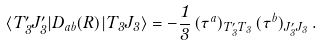Convert formula to latex. <formula><loc_0><loc_0><loc_500><loc_500>\langle T _ { 3 } ^ { \prime } J _ { 3 } ^ { \prime } | D _ { a b } ( R ) | T _ { 3 } J _ { 3 } \rangle = - \frac { 1 } { 3 } \, ( \tau ^ { a } ) _ { T _ { 3 } ^ { \prime } T _ { 3 } } \, ( \tau ^ { b } ) _ { J _ { 3 } ^ { \prime } J _ { 3 } } \, .</formula> 